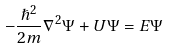Convert formula to latex. <formula><loc_0><loc_0><loc_500><loc_500>- \frac { \hslash ^ { 2 } } { 2 m } \nabla ^ { 2 } \Psi + U \Psi = E \Psi</formula> 